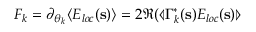<formula> <loc_0><loc_0><loc_500><loc_500>F _ { k } = \partial _ { { \boldsymbol \theta } _ { k } } \langle E _ { l o c } ( s ) \rangle = 2 \Re ( \ll a n g l e \Gamma _ { k } ^ { * } ( s ) E _ { l o c } ( s ) \ r r a n g l e</formula> 